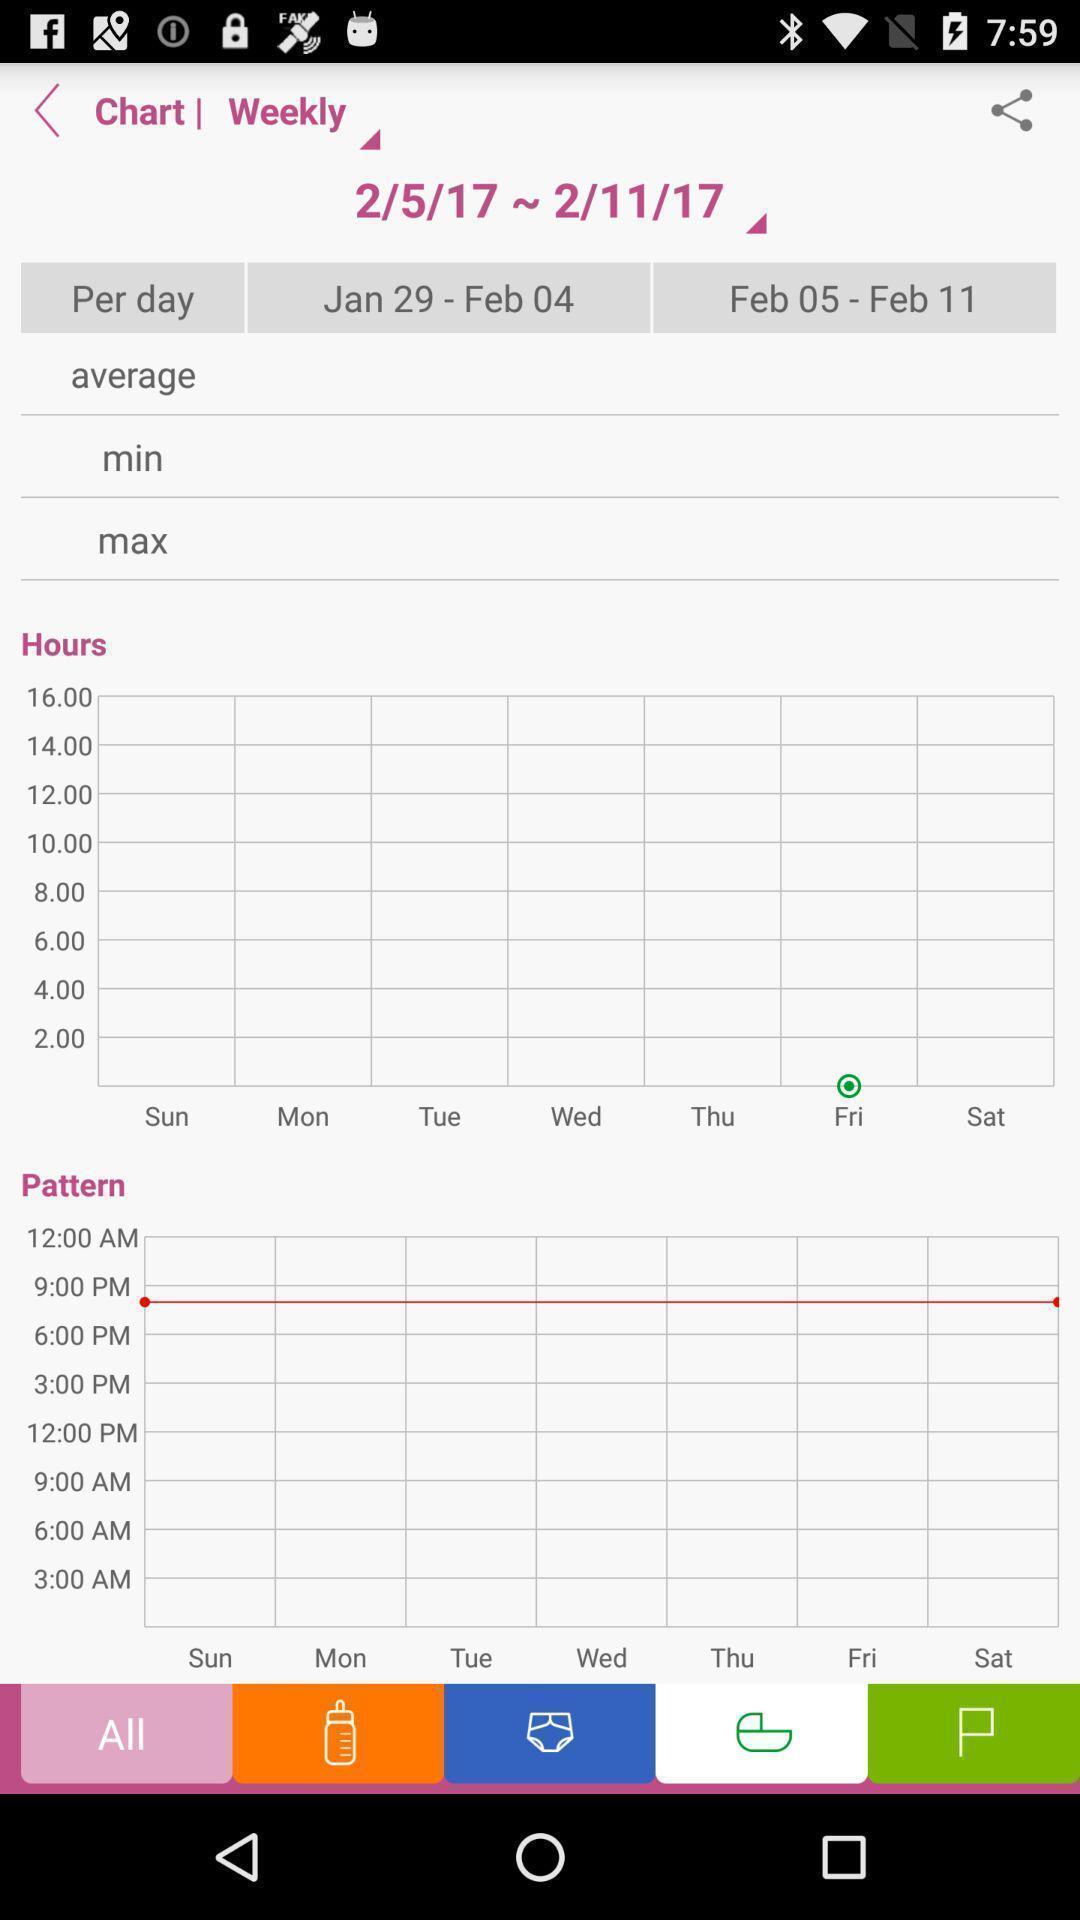Provide a textual representation of this image. Screen displaying the chart page. 